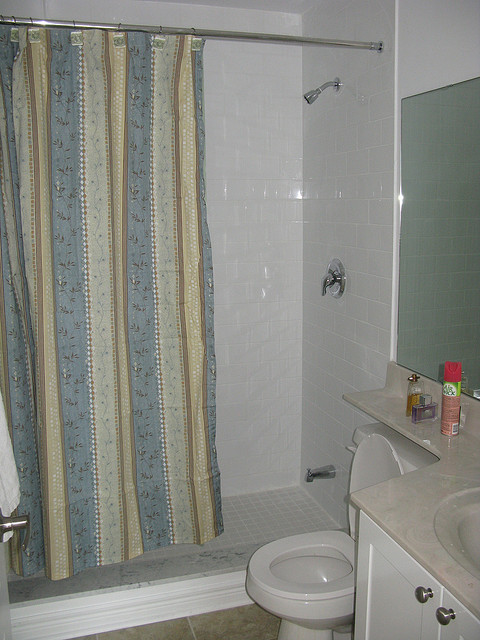<image>What model toilet is this? It is unknown what model the toilet is. It could possibly be a Kohler. What model toilet is this? I don't know what model toilet this is. 